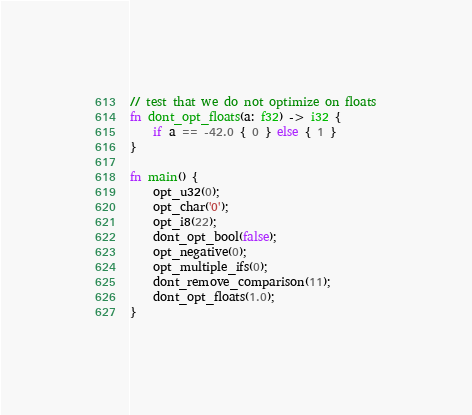<code> <loc_0><loc_0><loc_500><loc_500><_Rust_>
// test that we do not optimize on floats
fn dont_opt_floats(a: f32) -> i32 {
    if a == -42.0 { 0 } else { 1 }
}

fn main() {
    opt_u32(0);
    opt_char('0');
    opt_i8(22);
    dont_opt_bool(false);
    opt_negative(0);
    opt_multiple_ifs(0);
    dont_remove_comparison(11);
    dont_opt_floats(1.0);
}
</code> 